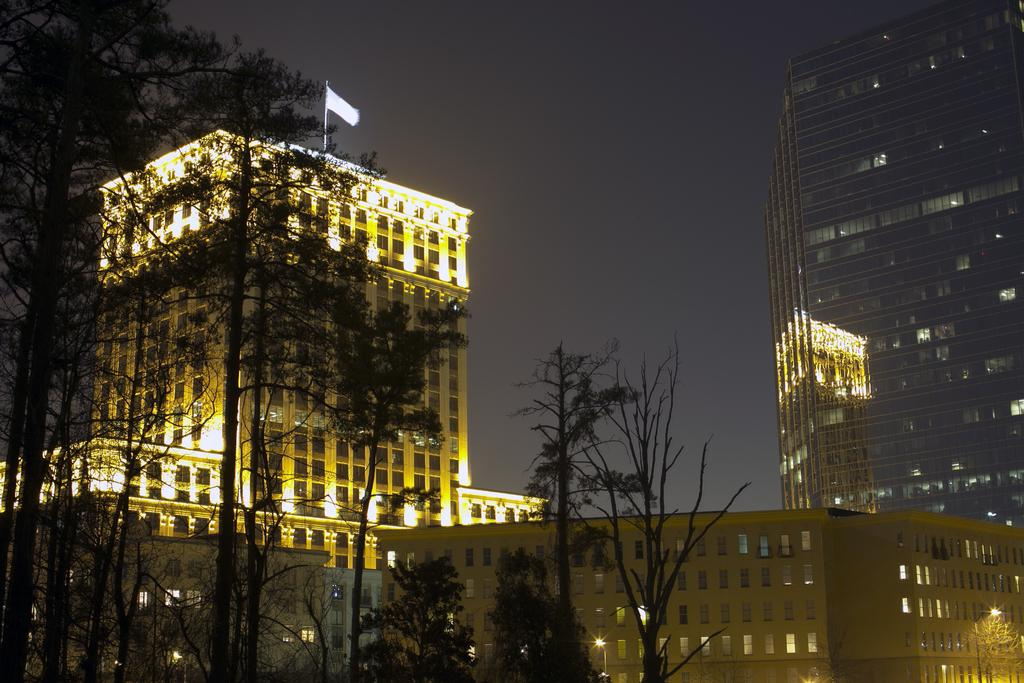What type of natural elements can be seen in the image? There are trees in the image. What type of man-made structures are present in the image? There are buildings in the image. What part of the natural environment is visible in the image? The sky is visible in the image. What type of ear is visible on the tree in the image? There are no ears present in the image, as it features trees, buildings, and the sky. 